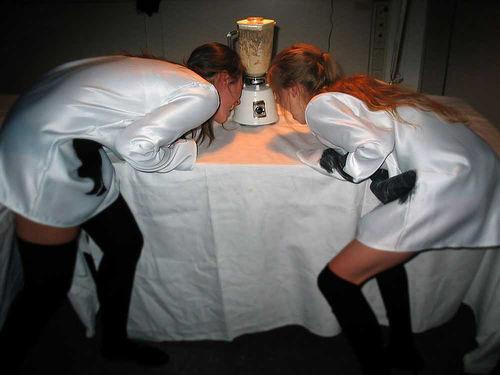How many girls are present?
Give a very brief answer. 2. How many people are there?
Give a very brief answer. 2. 